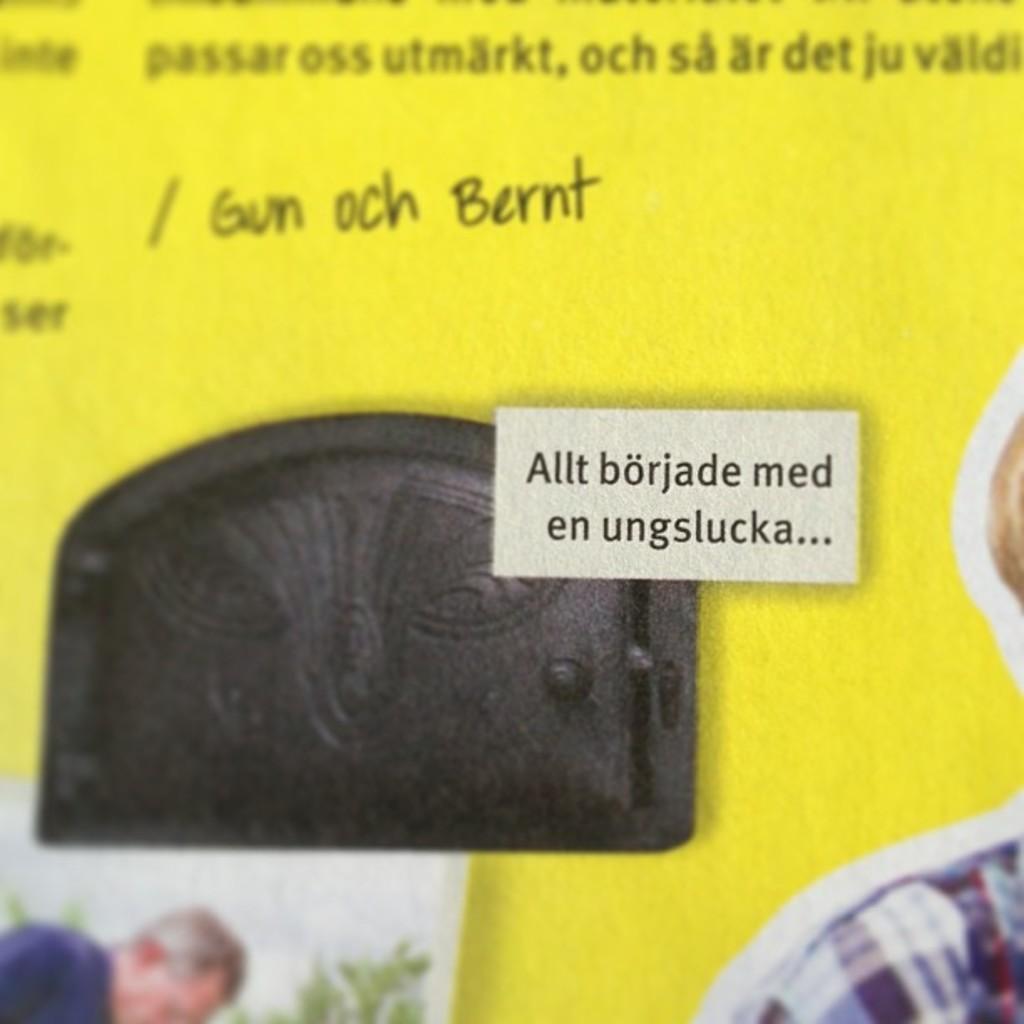How would you summarize this image in a sentence or two? In this image, we can see a picture and some text on the yellow background. 